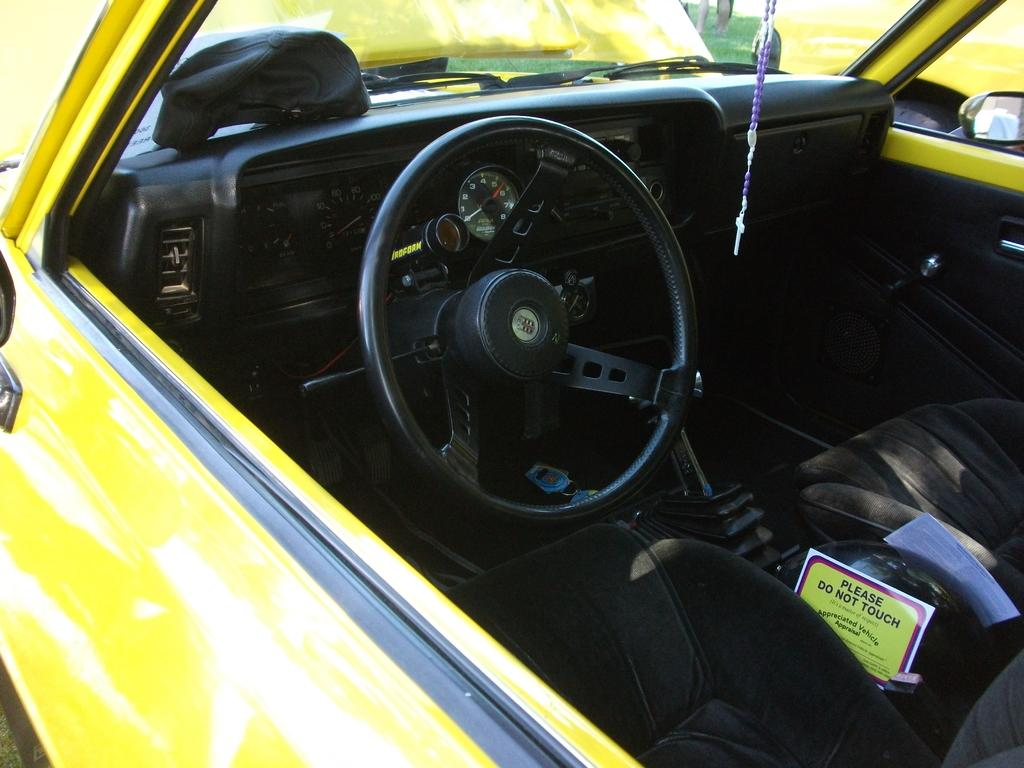What type of vehicle is shown in the image? The image contains the interior of a car. What can be seen in the car's interior? The steering of the car is visible in the image. What type of bike is hanging from the ceiling in the image? There is no bike present in the image; it only shows the interior of a car. 